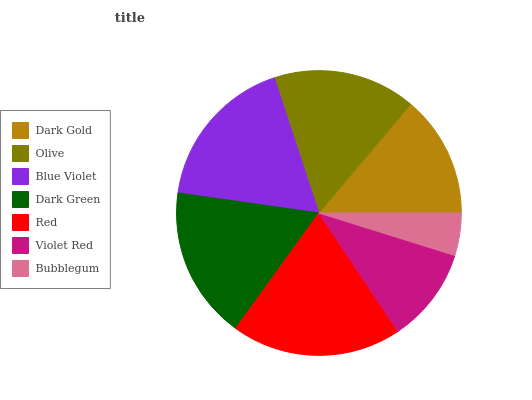Is Bubblegum the minimum?
Answer yes or no. Yes. Is Red the maximum?
Answer yes or no. Yes. Is Olive the minimum?
Answer yes or no. No. Is Olive the maximum?
Answer yes or no. No. Is Olive greater than Dark Gold?
Answer yes or no. Yes. Is Dark Gold less than Olive?
Answer yes or no. Yes. Is Dark Gold greater than Olive?
Answer yes or no. No. Is Olive less than Dark Gold?
Answer yes or no. No. Is Olive the high median?
Answer yes or no. Yes. Is Olive the low median?
Answer yes or no. Yes. Is Violet Red the high median?
Answer yes or no. No. Is Violet Red the low median?
Answer yes or no. No. 